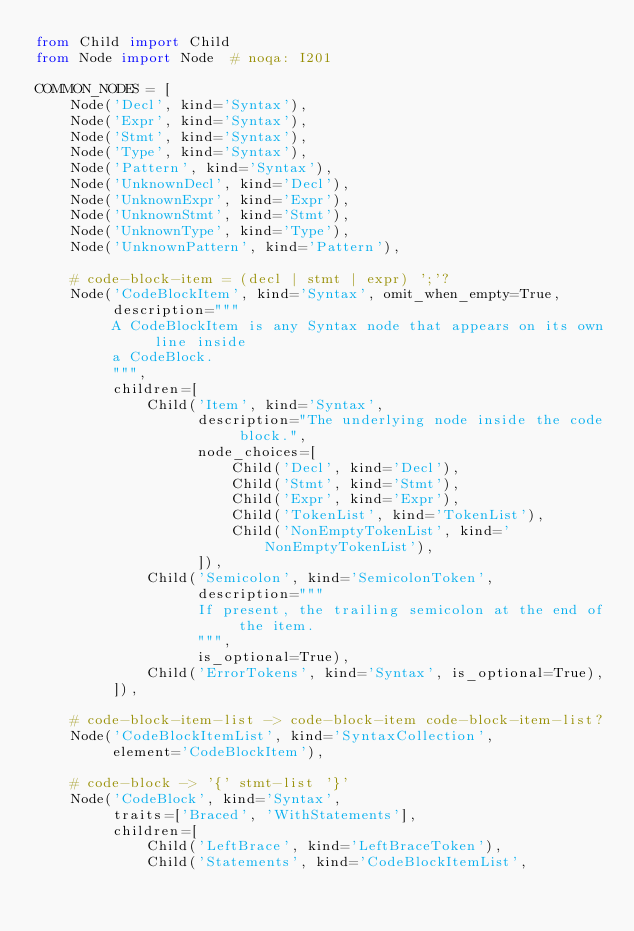Convert code to text. <code><loc_0><loc_0><loc_500><loc_500><_Python_>from Child import Child
from Node import Node  # noqa: I201

COMMON_NODES = [
    Node('Decl', kind='Syntax'),
    Node('Expr', kind='Syntax'),
    Node('Stmt', kind='Syntax'),
    Node('Type', kind='Syntax'),
    Node('Pattern', kind='Syntax'),
    Node('UnknownDecl', kind='Decl'),
    Node('UnknownExpr', kind='Expr'),
    Node('UnknownStmt', kind='Stmt'),
    Node('UnknownType', kind='Type'),
    Node('UnknownPattern', kind='Pattern'),

    # code-block-item = (decl | stmt | expr) ';'?
    Node('CodeBlockItem', kind='Syntax', omit_when_empty=True,
         description="""
         A CodeBlockItem is any Syntax node that appears on its own line inside
         a CodeBlock.
         """,
         children=[
             Child('Item', kind='Syntax',
                   description="The underlying node inside the code block.",
                   node_choices=[
                       Child('Decl', kind='Decl'),
                       Child('Stmt', kind='Stmt'),
                       Child('Expr', kind='Expr'),
                       Child('TokenList', kind='TokenList'),
                       Child('NonEmptyTokenList', kind='NonEmptyTokenList'),
                   ]),
             Child('Semicolon', kind='SemicolonToken',
                   description="""
                   If present, the trailing semicolon at the end of the item.
                   """,
                   is_optional=True),
             Child('ErrorTokens', kind='Syntax', is_optional=True),
         ]),

    # code-block-item-list -> code-block-item code-block-item-list?
    Node('CodeBlockItemList', kind='SyntaxCollection',
         element='CodeBlockItem'),

    # code-block -> '{' stmt-list '}'
    Node('CodeBlock', kind='Syntax',
         traits=['Braced', 'WithStatements'],
         children=[
             Child('LeftBrace', kind='LeftBraceToken'),
             Child('Statements', kind='CodeBlockItemList',</code> 